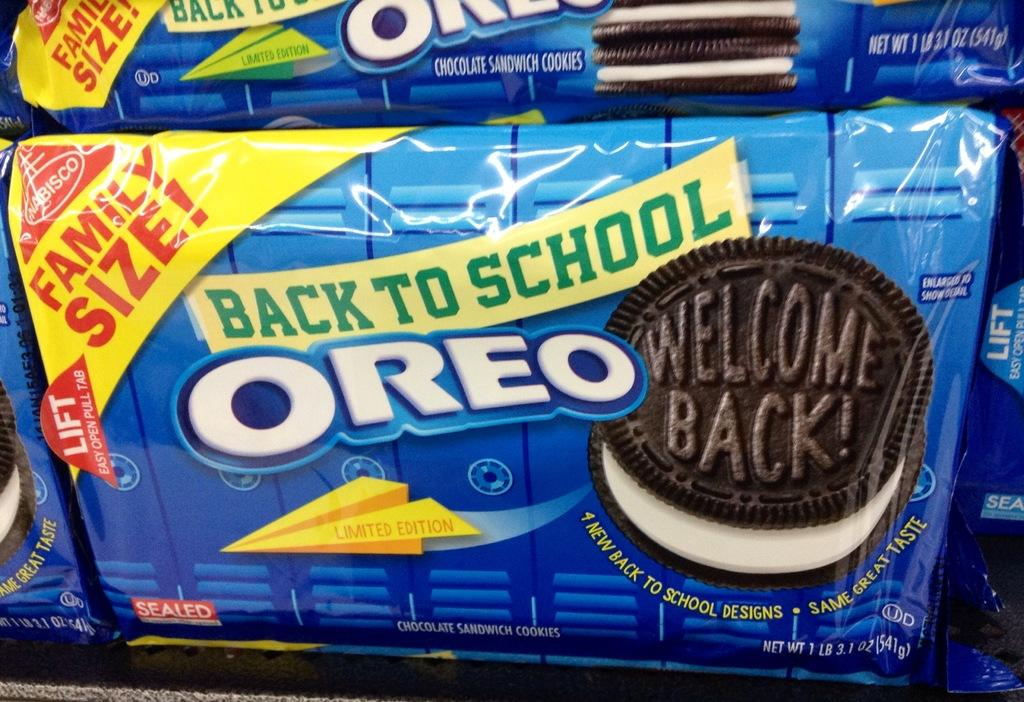<image>
Give a short and clear explanation of the subsequent image. A package of Oreos that is labeled back to school 